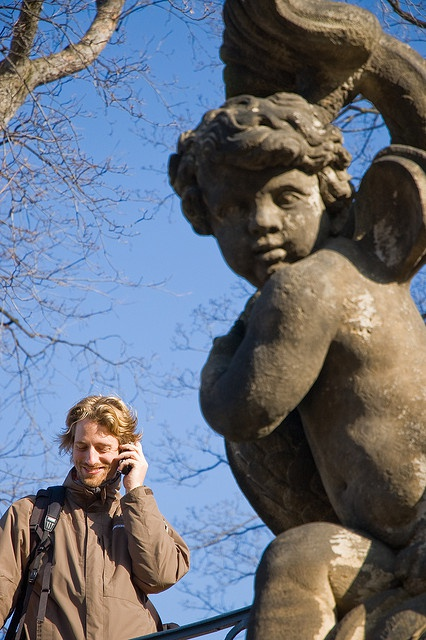Describe the objects in this image and their specific colors. I can see people in gray, black, and tan tones, backpack in gray, black, and darkgray tones, handbag in gray, black, and darkgray tones, and cell phone in gray, black, maroon, and brown tones in this image. 